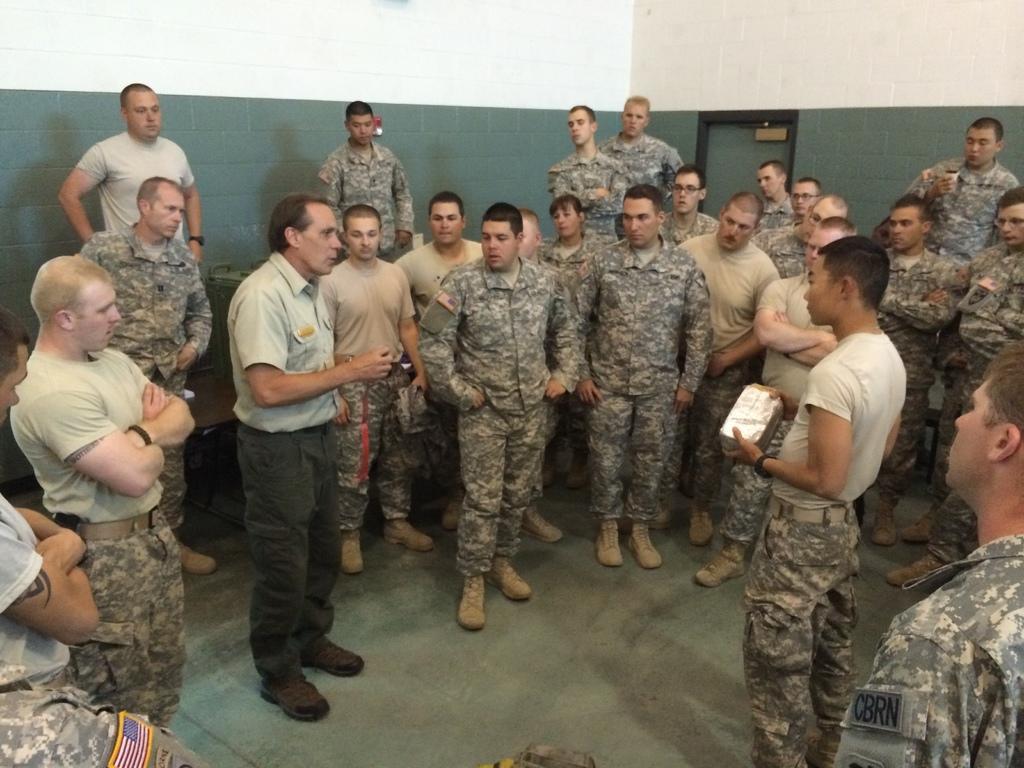Describe this image in one or two sentences. In this image we can see men are standing. They are wearing army uniform. We can see white and green color walls in the background. 